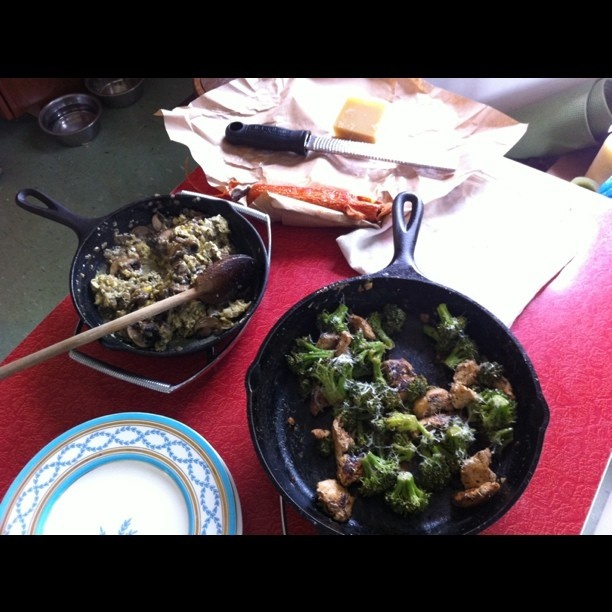Describe the objects in this image and their specific colors. I can see dining table in black, white, maroon, and gray tones, broccoli in black, darkgreen, and gray tones, spoon in black, gray, and maroon tones, broccoli in black, darkgreen, and gray tones, and knife in black, white, navy, and darkgray tones in this image. 